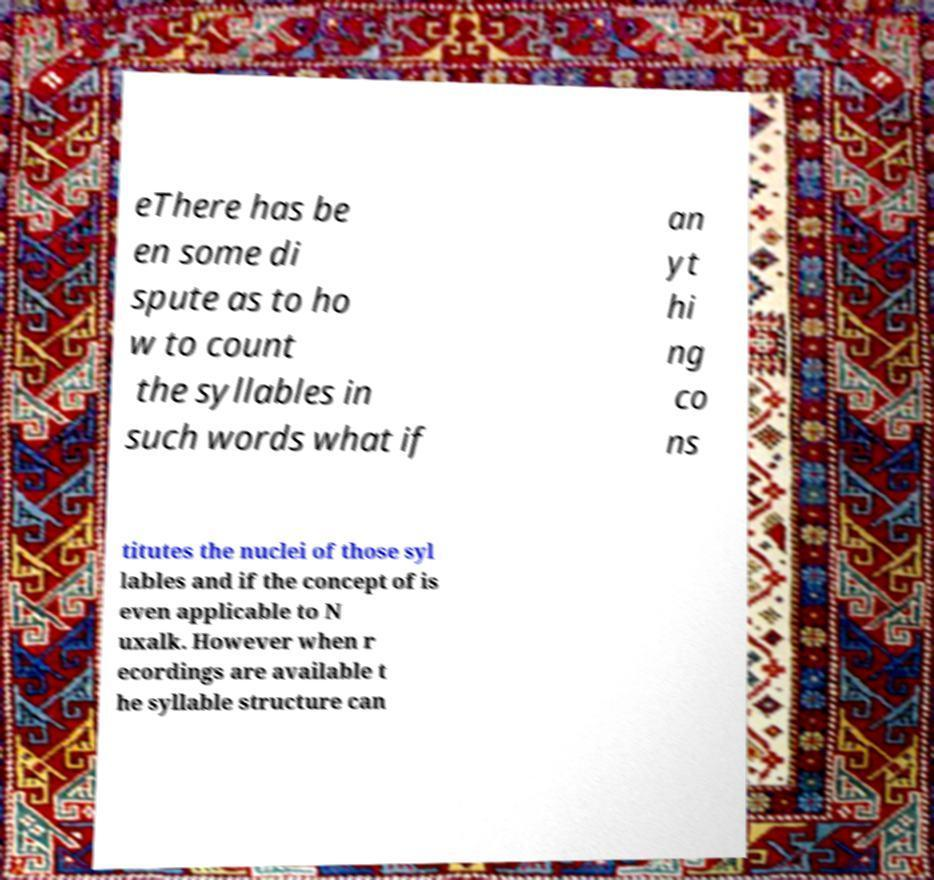For documentation purposes, I need the text within this image transcribed. Could you provide that? eThere has be en some di spute as to ho w to count the syllables in such words what if an yt hi ng co ns titutes the nuclei of those syl lables and if the concept of is even applicable to N uxalk. However when r ecordings are available t he syllable structure can 